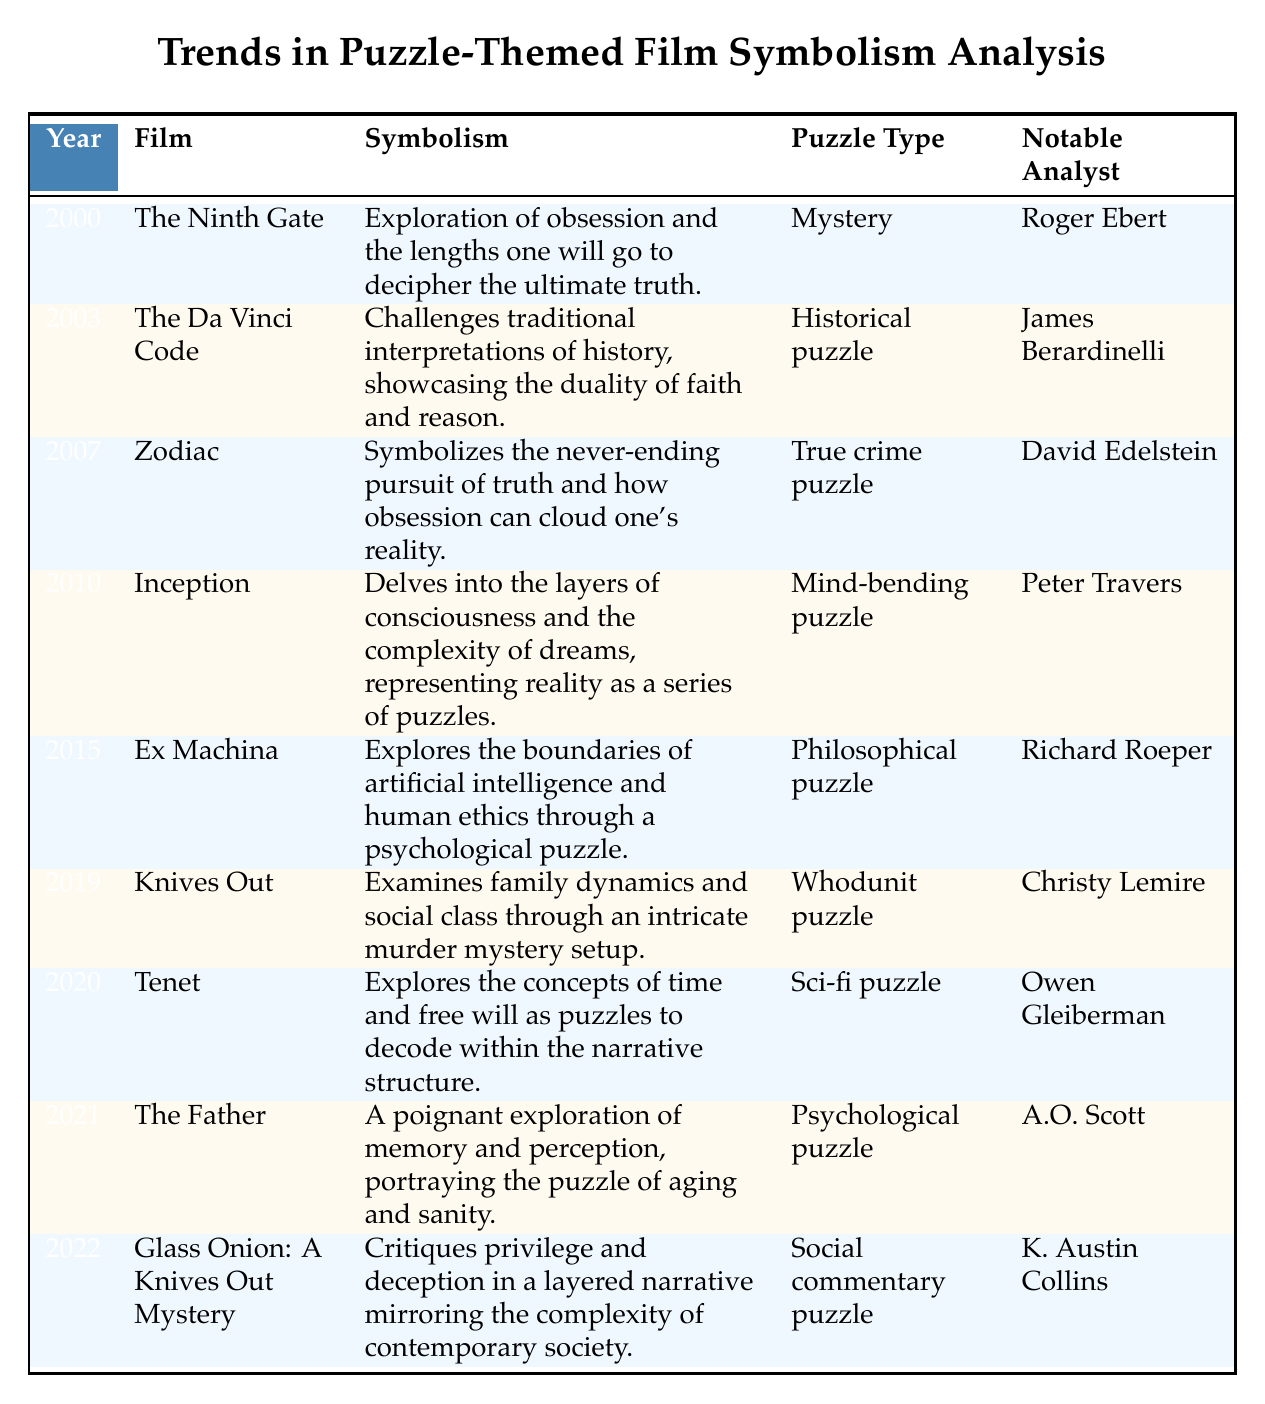What film released in 2015 explores artificial intelligence through a psychological puzzle? The table shows that "Ex Machina" released in 2015 and is described as exploring artificial intelligence and human ethics through a psychological puzzle.
Answer: Ex Machina Who analyzed the symbolism in "Inception"? According to the table, the notable analyst for "Inception" in 2010 is Peter Travers.
Answer: Peter Travers How many films in the table are categorized as "Mystery" puzzles? The table lists one film classified as a "Mystery" puzzle, which is "The Ninth Gate" from the year 2000.
Answer: 1 Was "Knives Out" released before 2020? Looking at the table, "Knives Out" was released in 2019, which is before 2020.
Answer: Yes Which film's symbolism critiques privilege and deception? By examining the table, it is evident that "Glass Onion: A Knives Out Mystery" from 2022 critiques privilege and deception through its layered narrative.
Answer: Glass Onion: A Knives Out Mystery What is the average year of release for all films listed? The years of release are 2000, 2003, 2007, 2010, 2015, 2019, 2020, 2021, and 2022. Adding them gives 2000 + 2003 + 2007 + 2010 + 2015 + 2019 + 2020 + 2021 + 2022 = 18007. There are 9 films, so the average year is 18007 / 9 = 2001.89, which rounds to 2002.
Answer: 2002 Which two films feature notable analysts with last names starting with 'B'? Reviewing the table, "The Da Vinci Code" (James Berardinelli) and "Tenet" (Owen Gleiberman) both have analysts' names that start with 'B', while "Ex Machina" with Richard Roeper does not. Therefore, the films are "The Da Vinci Code" and "Tenet."
Answer: The Da Vinci Code, Tenet What unique theme does the film "The Father" explore in relation to puzzles? The symbolism of "The Father" from 2021 explores the puzzle of aging and sanity, focusing on memory and perception.
Answer: Aging and sanity Which film analyzed by Christy Lemire depicts social class dynamics? The table indicates that "Knives Out," analyzed by Christy Lemire, examines family dynamics and social class through its intricate murder mystery setup.
Answer: Knives Out 